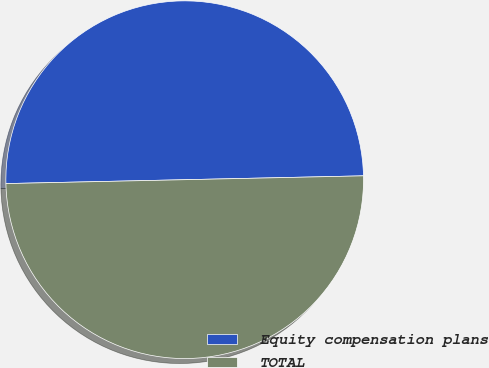Convert chart. <chart><loc_0><loc_0><loc_500><loc_500><pie_chart><fcel>Equity compensation plans<fcel>TOTAL<nl><fcel>50.0%<fcel>50.0%<nl></chart> 